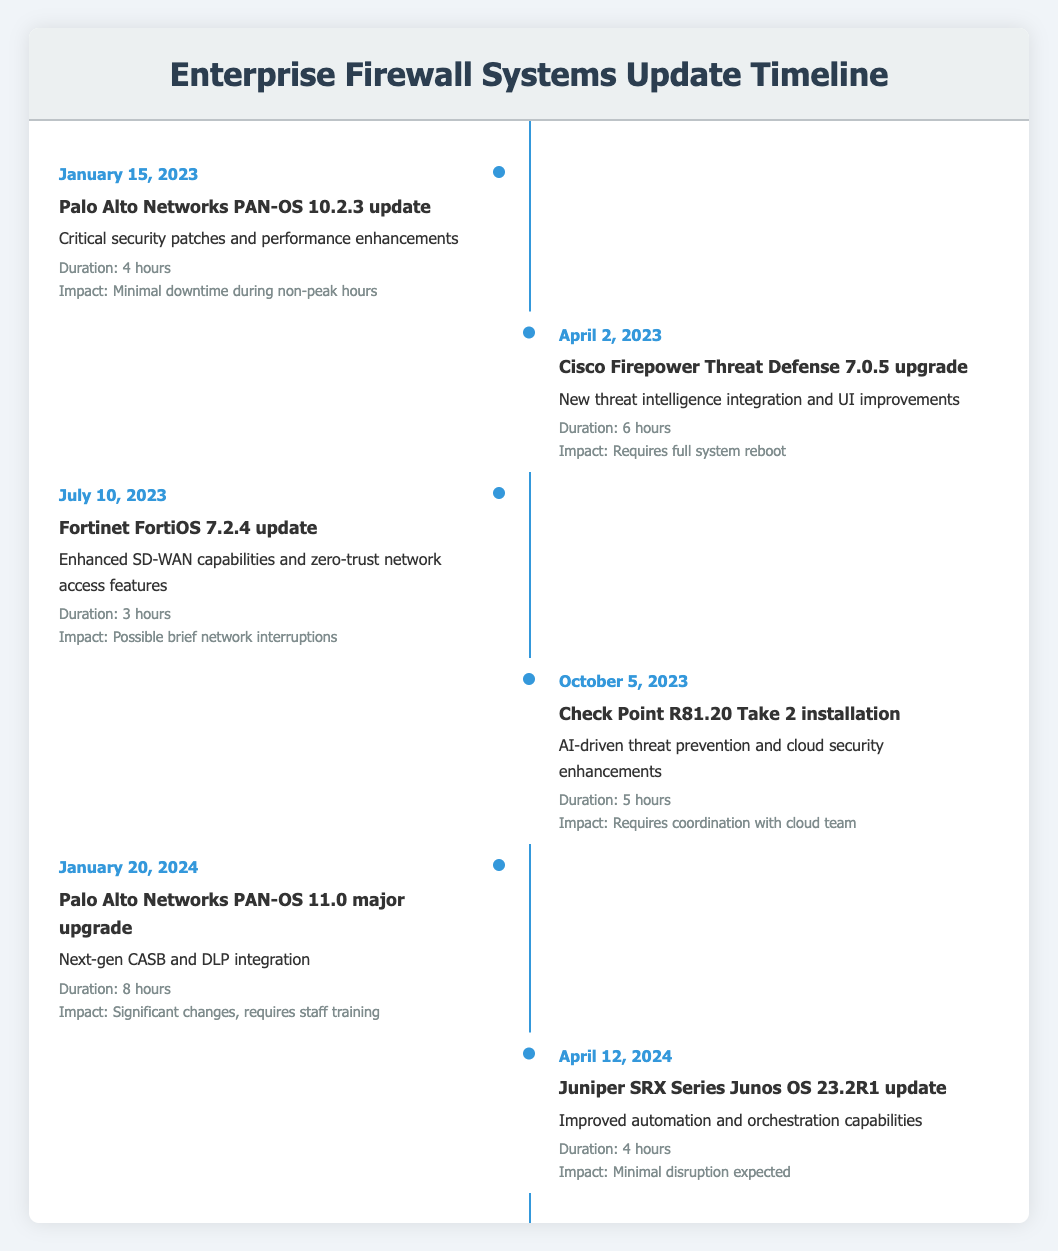What event occurred on April 2, 2023? The table shows that on April 2, 2023, the event was the "Cisco Firepower Threat Defense 7.0.5 upgrade." This can be directly retrieved from the "date" that corresponds to that entry.
Answer: Cisco Firepower Threat Defense 7.0.5 upgrade How long did the Check Point R81.20 Take 2 installation take? According to the table, the duration of the Check Point R81.20 Take 2 installation, which occurred on October 5, 2023, was 5 hours. This information is directly provided in the "duration" column for that event.
Answer: 5 hours What is the impact of the Palo Alto Networks PAN-OS 11.0 major upgrade? The impact of the Palo Alto Networks PAN-OS 11.0 major upgrade, as listed in the table, is "Significant changes, requires staff training." This is found in the corresponding "impact" section for the event on January 20, 2024.
Answer: Significant changes, requires staff training Is a full system reboot required for the Cisco Firepower Threat Defense 7.0.5 upgrade? Yes, the table indicates that the Cisco Firepower Threat Defense 7.0.5 upgrade requires a full system reboot, as stated in the impact description of the April 2, 2023 event.
Answer: Yes What are the total hours required for the updates happening in the first half of 2023? First, we need to extract the durations of the updates that took place in the first half of 2023. These are 4 hours for the Palo Alto Networks update and 6 hours for the Cisco Firepower upgrade. Adding these together gives us a total of 4 + 6 = 10 hours. Therefore, the total hours required for these updates is 10.
Answer: 10 hours How many updates have a minimal disruption impact? The updates with minimal disruption impacts are the Palo Alto Networks PAN-OS 10.2.3 update, which has a minimal downtime, and the Juniper SRX Series Junos OS 23.2R1 update, expected to cause minimal disruption. There are 2 such instances.
Answer: 2 What are the durations of the updates required for significant changes? The only update that mentions significant changes is the Palo Alto Networks PAN-OS 11.0 major upgrade, which requires 8 hours. No other updates listed mention significant changes.
Answer: 8 hours Which updates have possible network interruptions expected? According to the timeline, the Fortinet FortiOS 7.2.4 update on July 10, 2023, is noted to have "Possible brief network interruptions" as its impact. There is only one event matching this description.
Answer: Fortinet FortiOS 7.2.4 update What is the earliest scheduled update event from the timeline? The earliest scheduled update event in the table is the Palo Alto Networks PAN-OS 10.2.3 update on January 15, 2023. This can be found by looking at the dates in chronological order.
Answer: January 15, 2023 